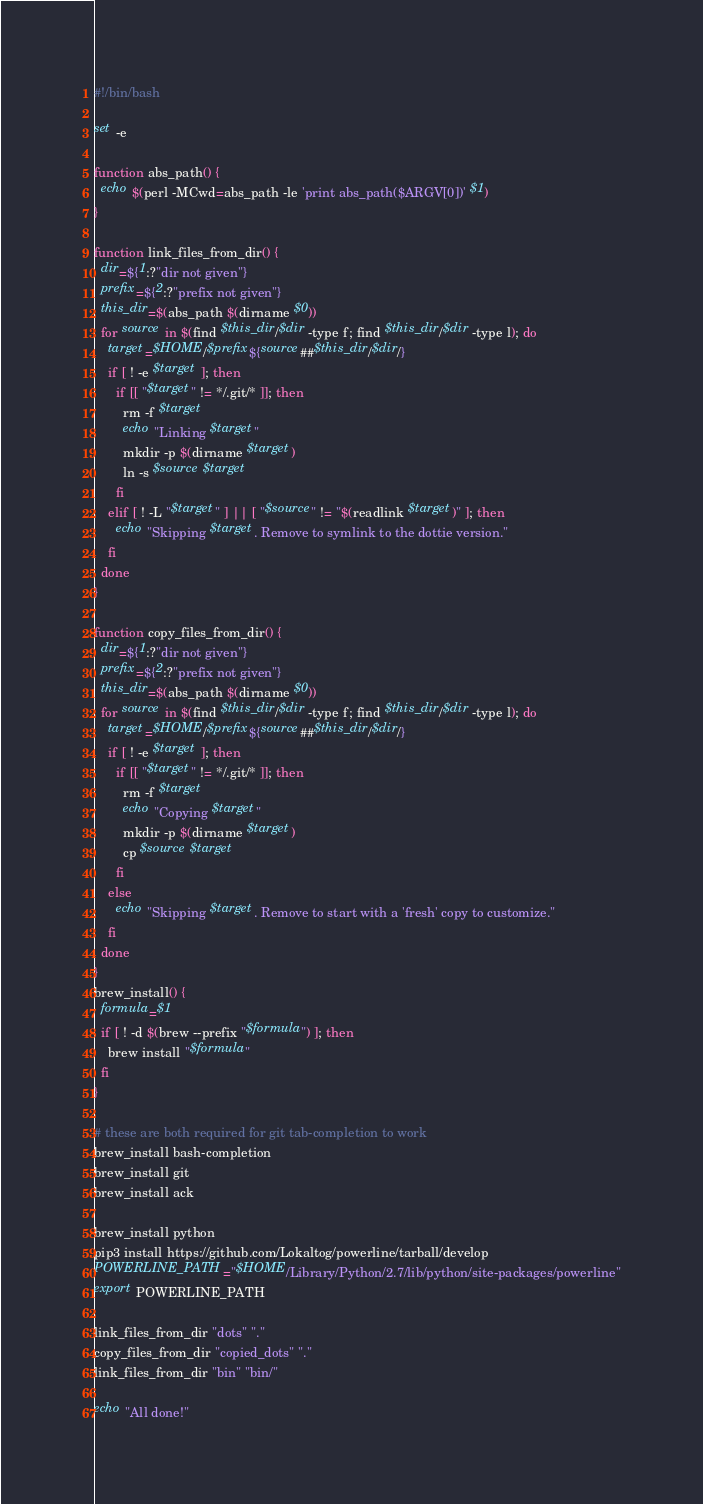Convert code to text. <code><loc_0><loc_0><loc_500><loc_500><_Bash_>#!/bin/bash

set -e

function abs_path() {
  echo $(perl -MCwd=abs_path -le 'print abs_path($ARGV[0])' $1)
}

function link_files_from_dir() {
  dir=${1:?"dir not given"}
  prefix=${2:?"prefix not given"}
  this_dir=$(abs_path $(dirname $0))
  for source in $(find $this_dir/$dir -type f; find $this_dir/$dir -type l); do
    target=$HOME/$prefix${source##$this_dir/$dir/}
    if [ ! -e $target ]; then
      if [[ "$target" != */.git/* ]]; then
        rm -f $target
        echo "Linking $target"
        mkdir -p $(dirname $target)
        ln -s $source $target
      fi
    elif [ ! -L "$target" ] || [ "$source" != "$(readlink $target)" ]; then
      echo "Skipping $target. Remove to symlink to the dottie version."
    fi
  done
}

function copy_files_from_dir() {
  dir=${1:?"dir not given"}
  prefix=${2:?"prefix not given"}
  this_dir=$(abs_path $(dirname $0))
  for source in $(find $this_dir/$dir -type f; find $this_dir/$dir -type l); do
    target=$HOME/$prefix${source##$this_dir/$dir/}
    if [ ! -e $target ]; then
      if [[ "$target" != */.git/* ]]; then
        rm -f $target
        echo "Copying $target"
        mkdir -p $(dirname $target)
        cp $source $target
      fi
    else
      echo "Skipping $target. Remove to start with a 'fresh' copy to customize."
    fi
  done
}
brew_install() {
  formula=$1
  if [ ! -d $(brew --prefix "$formula") ]; then
    brew install "$formula"
  fi
}

# these are both required for git tab-completion to work
brew_install bash-completion
brew_install git
brew_install ack

brew_install python
pip3 install https://github.com/Lokaltog/powerline/tarball/develop
POWERLINE_PATH="$HOME/Library/Python/2.7/lib/python/site-packages/powerline"
export POWERLINE_PATH

link_files_from_dir "dots" "."
copy_files_from_dir "copied_dots" "."
link_files_from_dir "bin" "bin/"

echo "All done!"
</code> 